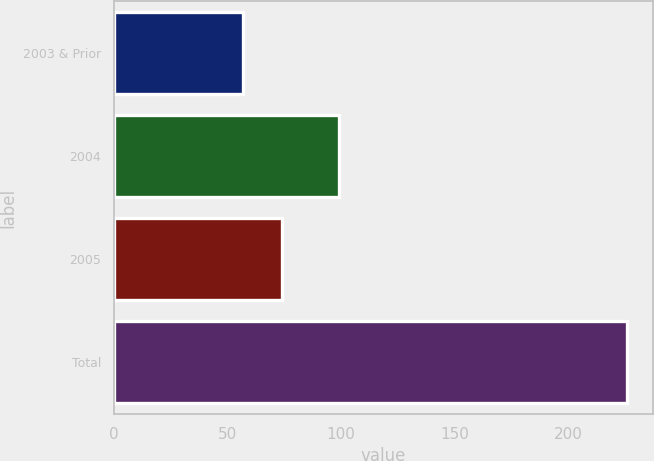Convert chart to OTSL. <chart><loc_0><loc_0><loc_500><loc_500><bar_chart><fcel>2003 & Prior<fcel>2004<fcel>2005<fcel>Total<nl><fcel>57<fcel>99<fcel>73.9<fcel>226<nl></chart> 